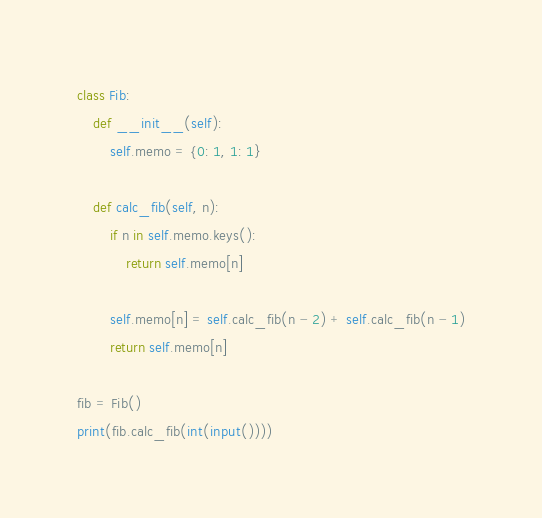Convert code to text. <code><loc_0><loc_0><loc_500><loc_500><_Python_>class Fib:
    def __init__(self):
        self.memo = {0: 1, 1: 1}
    
    def calc_fib(self, n):
        if n in self.memo.keys():
            return self.memo[n]
        
        self.memo[n] = self.calc_fib(n - 2) + self.calc_fib(n - 1)
        return self.memo[n]
    
fib = Fib()
print(fib.calc_fib(int(input())))
</code> 